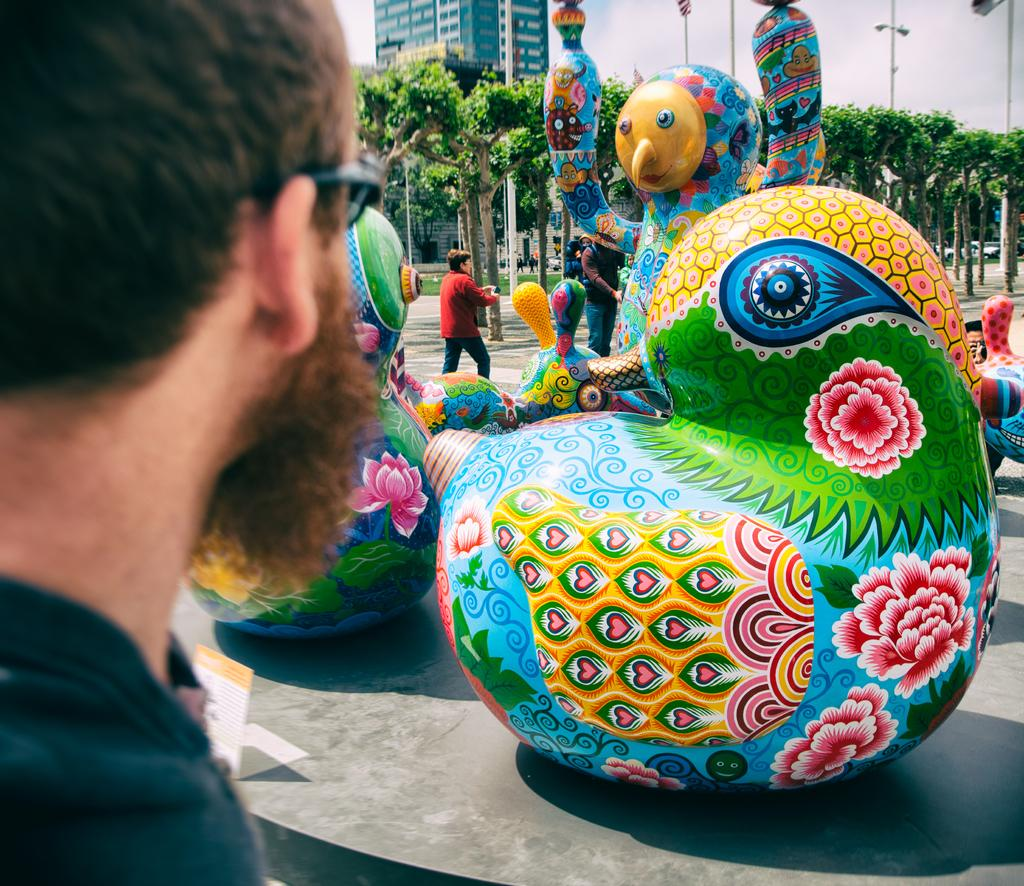Who or what can be seen in the image? There are people in the image. What kind of objects are present in the image? There are colorful objects in the image. What structures can be identified in the image? There are poles in the image. What type of vegetation is visible in the image? There are trees in the image. What type of man-made structure is present in the image? There is a building in the image. What is visible in the background of the image? The sky is visible in the background of the image. What is the temperature of the railway in the image? There is no railway present in the image, so it is not possible to determine its temperature. 